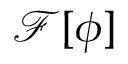Convert formula to latex. <formula><loc_0><loc_0><loc_500><loc_500>\mathcal { F [ { \phi } ] }</formula> 